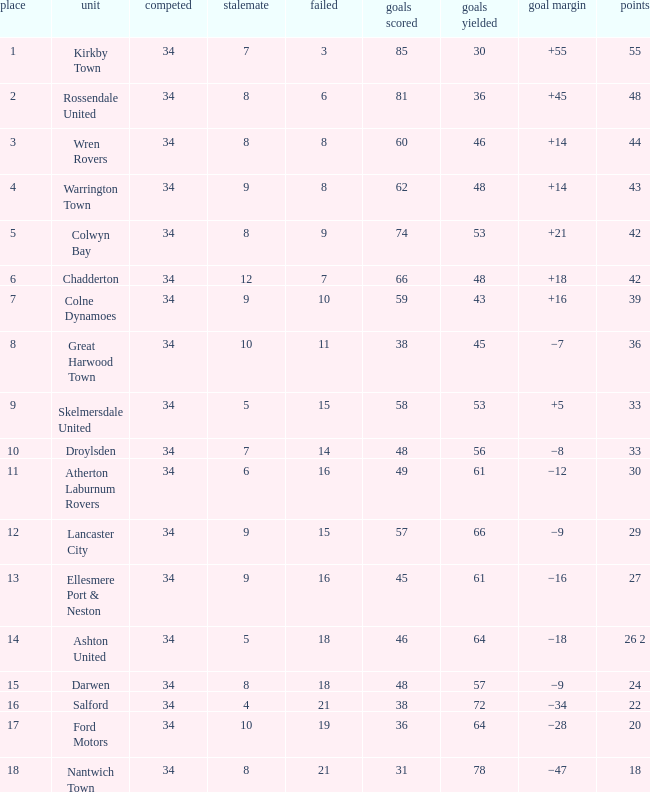What is the total number of goals for when the drawn is less than 7, less than 21 games have been lost, and there are 1 of 33 points? 1.0. 